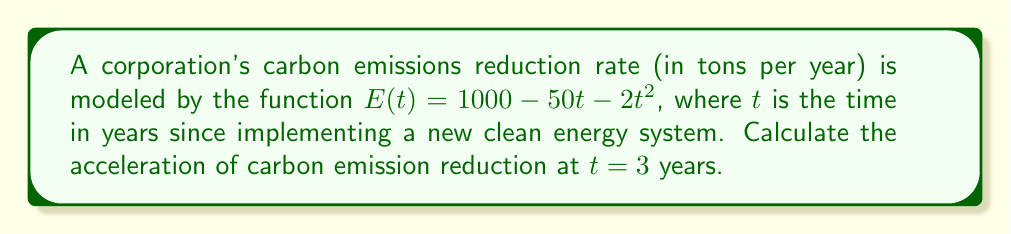Give your solution to this math problem. To find the acceleration of carbon emission reduction, we need to follow these steps:

1) The rate of carbon emission reduction is given by the first derivative of $E(t)$:
   $$E'(t) = -50 - 4t$$

2) The acceleration of carbon emission reduction is the second derivative of $E(t)$, which is the rate of change of the reduction rate:
   $$E''(t) = -4$$

3) The question asks for the acceleration at $t = 3$ years. Since $E''(t)$ is a constant function, the acceleration is the same at all times:
   $$E''(3) = -4$$

4) The negative value indicates that the rate of emission reduction is decreasing over time, meaning the company's efforts are becoming less effective as time progresses.

5) The units of acceleration are tons per year squared $(tons/year^2)$, as it represents the change in reduction rate (tons/year) per year.
Answer: $-4$ $tons/year^2$ 